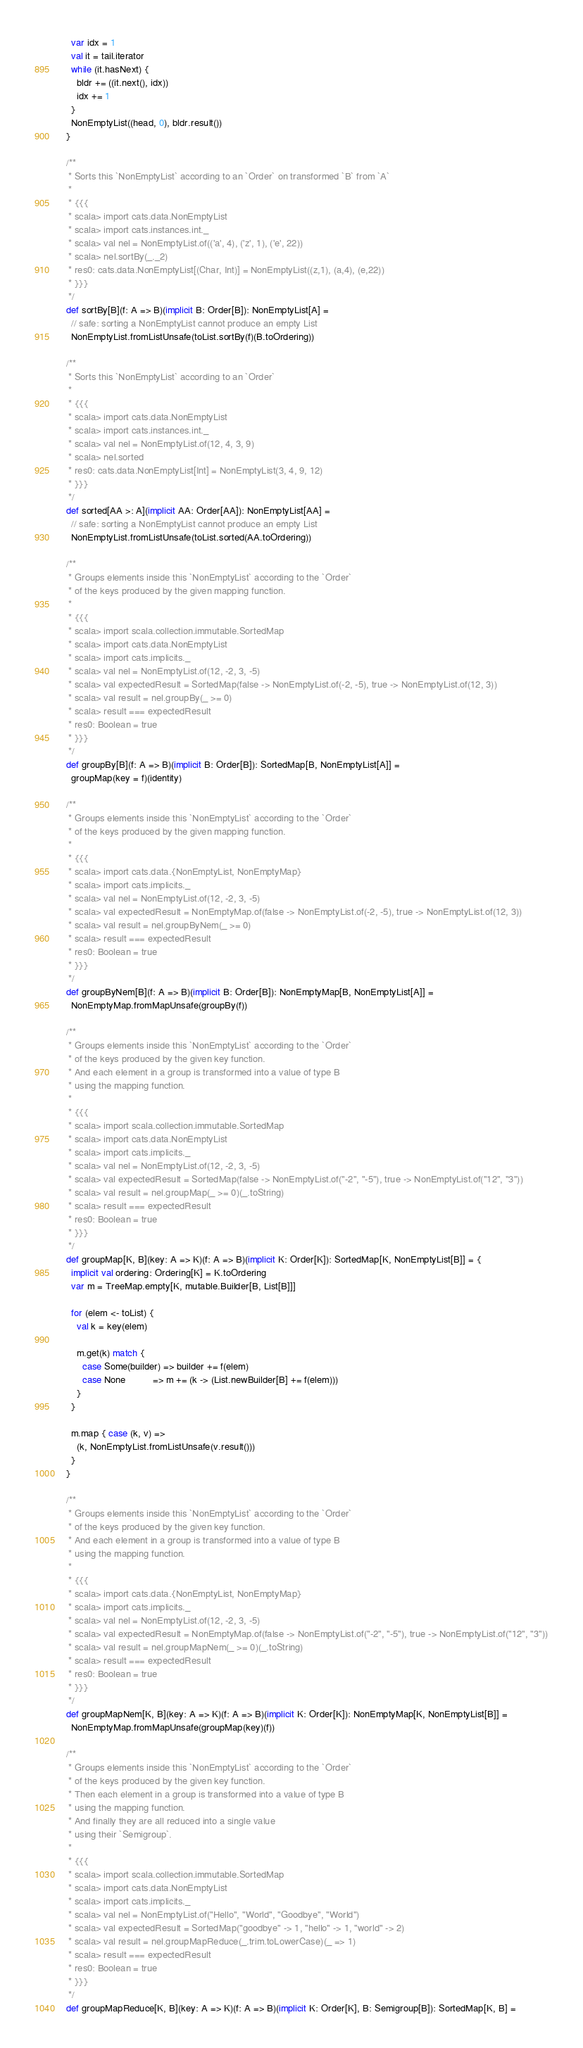<code> <loc_0><loc_0><loc_500><loc_500><_Scala_>    var idx = 1
    val it = tail.iterator
    while (it.hasNext) {
      bldr += ((it.next(), idx))
      idx += 1
    }
    NonEmptyList((head, 0), bldr.result())
  }

  /**
   * Sorts this `NonEmptyList` according to an `Order` on transformed `B` from `A`
   *
   * {{{
   * scala> import cats.data.NonEmptyList
   * scala> import cats.instances.int._
   * scala> val nel = NonEmptyList.of(('a', 4), ('z', 1), ('e', 22))
   * scala> nel.sortBy(_._2)
   * res0: cats.data.NonEmptyList[(Char, Int)] = NonEmptyList((z,1), (a,4), (e,22))
   * }}}
   */
  def sortBy[B](f: A => B)(implicit B: Order[B]): NonEmptyList[A] =
    // safe: sorting a NonEmptyList cannot produce an empty List
    NonEmptyList.fromListUnsafe(toList.sortBy(f)(B.toOrdering))

  /**
   * Sorts this `NonEmptyList` according to an `Order`
   *
   * {{{
   * scala> import cats.data.NonEmptyList
   * scala> import cats.instances.int._
   * scala> val nel = NonEmptyList.of(12, 4, 3, 9)
   * scala> nel.sorted
   * res0: cats.data.NonEmptyList[Int] = NonEmptyList(3, 4, 9, 12)
   * }}}
   */
  def sorted[AA >: A](implicit AA: Order[AA]): NonEmptyList[AA] =
    // safe: sorting a NonEmptyList cannot produce an empty List
    NonEmptyList.fromListUnsafe(toList.sorted(AA.toOrdering))

  /**
   * Groups elements inside this `NonEmptyList` according to the `Order`
   * of the keys produced by the given mapping function.
   *
   * {{{
   * scala> import scala.collection.immutable.SortedMap
   * scala> import cats.data.NonEmptyList
   * scala> import cats.implicits._
   * scala> val nel = NonEmptyList.of(12, -2, 3, -5)
   * scala> val expectedResult = SortedMap(false -> NonEmptyList.of(-2, -5), true -> NonEmptyList.of(12, 3))
   * scala> val result = nel.groupBy(_ >= 0)
   * scala> result === expectedResult
   * res0: Boolean = true
   * }}}
   */
  def groupBy[B](f: A => B)(implicit B: Order[B]): SortedMap[B, NonEmptyList[A]] =
    groupMap(key = f)(identity)

  /**
   * Groups elements inside this `NonEmptyList` according to the `Order`
   * of the keys produced by the given mapping function.
   *
   * {{{
   * scala> import cats.data.{NonEmptyList, NonEmptyMap}
   * scala> import cats.implicits._
   * scala> val nel = NonEmptyList.of(12, -2, 3, -5)
   * scala> val expectedResult = NonEmptyMap.of(false -> NonEmptyList.of(-2, -5), true -> NonEmptyList.of(12, 3))
   * scala> val result = nel.groupByNem(_ >= 0)
   * scala> result === expectedResult
   * res0: Boolean = true
   * }}}
   */
  def groupByNem[B](f: A => B)(implicit B: Order[B]): NonEmptyMap[B, NonEmptyList[A]] =
    NonEmptyMap.fromMapUnsafe(groupBy(f))

  /**
   * Groups elements inside this `NonEmptyList` according to the `Order`
   * of the keys produced by the given key function.
   * And each element in a group is transformed into a value of type B
   * using the mapping function.
   *
   * {{{
   * scala> import scala.collection.immutable.SortedMap
   * scala> import cats.data.NonEmptyList
   * scala> import cats.implicits._
   * scala> val nel = NonEmptyList.of(12, -2, 3, -5)
   * scala> val expectedResult = SortedMap(false -> NonEmptyList.of("-2", "-5"), true -> NonEmptyList.of("12", "3"))
   * scala> val result = nel.groupMap(_ >= 0)(_.toString)
   * scala> result === expectedResult
   * res0: Boolean = true
   * }}}
   */
  def groupMap[K, B](key: A => K)(f: A => B)(implicit K: Order[K]): SortedMap[K, NonEmptyList[B]] = {
    implicit val ordering: Ordering[K] = K.toOrdering
    var m = TreeMap.empty[K, mutable.Builder[B, List[B]]]

    for (elem <- toList) {
      val k = key(elem)

      m.get(k) match {
        case Some(builder) => builder += f(elem)
        case None          => m += (k -> (List.newBuilder[B] += f(elem)))
      }
    }

    m.map { case (k, v) =>
      (k, NonEmptyList.fromListUnsafe(v.result()))
    }
  }

  /**
   * Groups elements inside this `NonEmptyList` according to the `Order`
   * of the keys produced by the given key function.
   * And each element in a group is transformed into a value of type B
   * using the mapping function.
   *
   * {{{
   * scala> import cats.data.{NonEmptyList, NonEmptyMap}
   * scala> import cats.implicits._
   * scala> val nel = NonEmptyList.of(12, -2, 3, -5)
   * scala> val expectedResult = NonEmptyMap.of(false -> NonEmptyList.of("-2", "-5"), true -> NonEmptyList.of("12", "3"))
   * scala> val result = nel.groupMapNem(_ >= 0)(_.toString)
   * scala> result === expectedResult
   * res0: Boolean = true
   * }}}
   */
  def groupMapNem[K, B](key: A => K)(f: A => B)(implicit K: Order[K]): NonEmptyMap[K, NonEmptyList[B]] =
    NonEmptyMap.fromMapUnsafe(groupMap(key)(f))

  /**
   * Groups elements inside this `NonEmptyList` according to the `Order`
   * of the keys produced by the given key function.
   * Then each element in a group is transformed into a value of type B
   * using the mapping function.
   * And finally they are all reduced into a single value
   * using their `Semigroup`.
   *
   * {{{
   * scala> import scala.collection.immutable.SortedMap
   * scala> import cats.data.NonEmptyList
   * scala> import cats.implicits._
   * scala> val nel = NonEmptyList.of("Hello", "World", "Goodbye", "World")
   * scala> val expectedResult = SortedMap("goodbye" -> 1, "hello" -> 1, "world" -> 2)
   * scala> val result = nel.groupMapReduce(_.trim.toLowerCase)(_ => 1)
   * scala> result === expectedResult
   * res0: Boolean = true
   * }}}
   */
  def groupMapReduce[K, B](key: A => K)(f: A => B)(implicit K: Order[K], B: Semigroup[B]): SortedMap[K, B] =</code> 